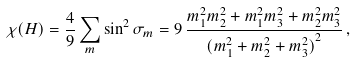Convert formula to latex. <formula><loc_0><loc_0><loc_500><loc_500>\chi ( H ) = \frac { 4 } { 9 } \sum _ { m } \sin ^ { 2 } \sigma _ { m } = 9 \, \frac { m _ { 1 } ^ { 2 } m _ { 2 } ^ { 2 } + m _ { 1 } ^ { 2 } m _ { 3 } ^ { 2 } + m _ { 2 } ^ { 2 } m _ { 3 } ^ { 2 } } { { ( m _ { 1 } ^ { 2 } + m _ { 2 } ^ { 2 } + m _ { 3 } ^ { 2 } ) } ^ { 2 } } \, ,</formula> 